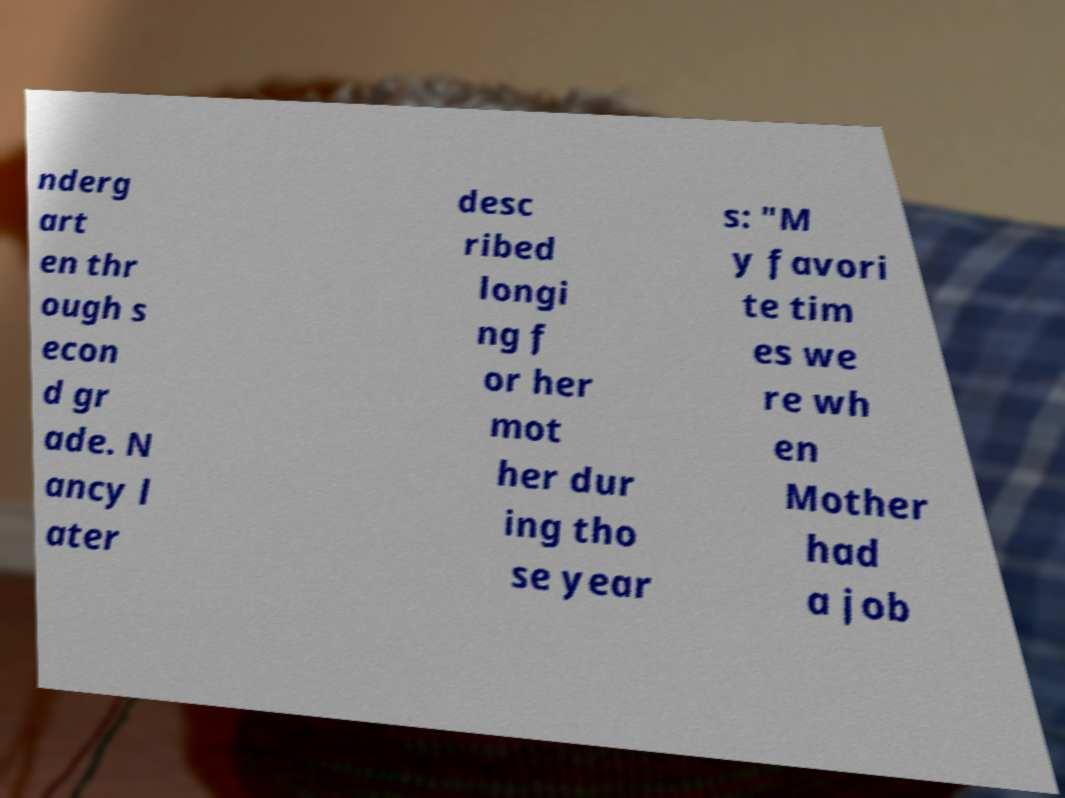Please read and relay the text visible in this image. What does it say? nderg art en thr ough s econ d gr ade. N ancy l ater desc ribed longi ng f or her mot her dur ing tho se year s: "M y favori te tim es we re wh en Mother had a job 